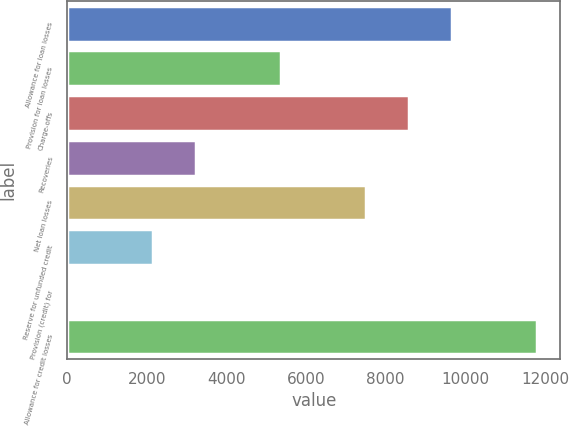Convert chart to OTSL. <chart><loc_0><loc_0><loc_500><loc_500><bar_chart><fcel>Allowance for loan losses<fcel>Provision for loan losses<fcel>Charge-offs<fcel>Recoveries<fcel>Net loan losses<fcel>Reserve for unfunded credit<fcel>Provision (credit) for<fcel>Allowance for credit losses<nl><fcel>9655.3<fcel>5368.5<fcel>8583.6<fcel>3225.1<fcel>7511.9<fcel>2153.4<fcel>10<fcel>11798.7<nl></chart> 